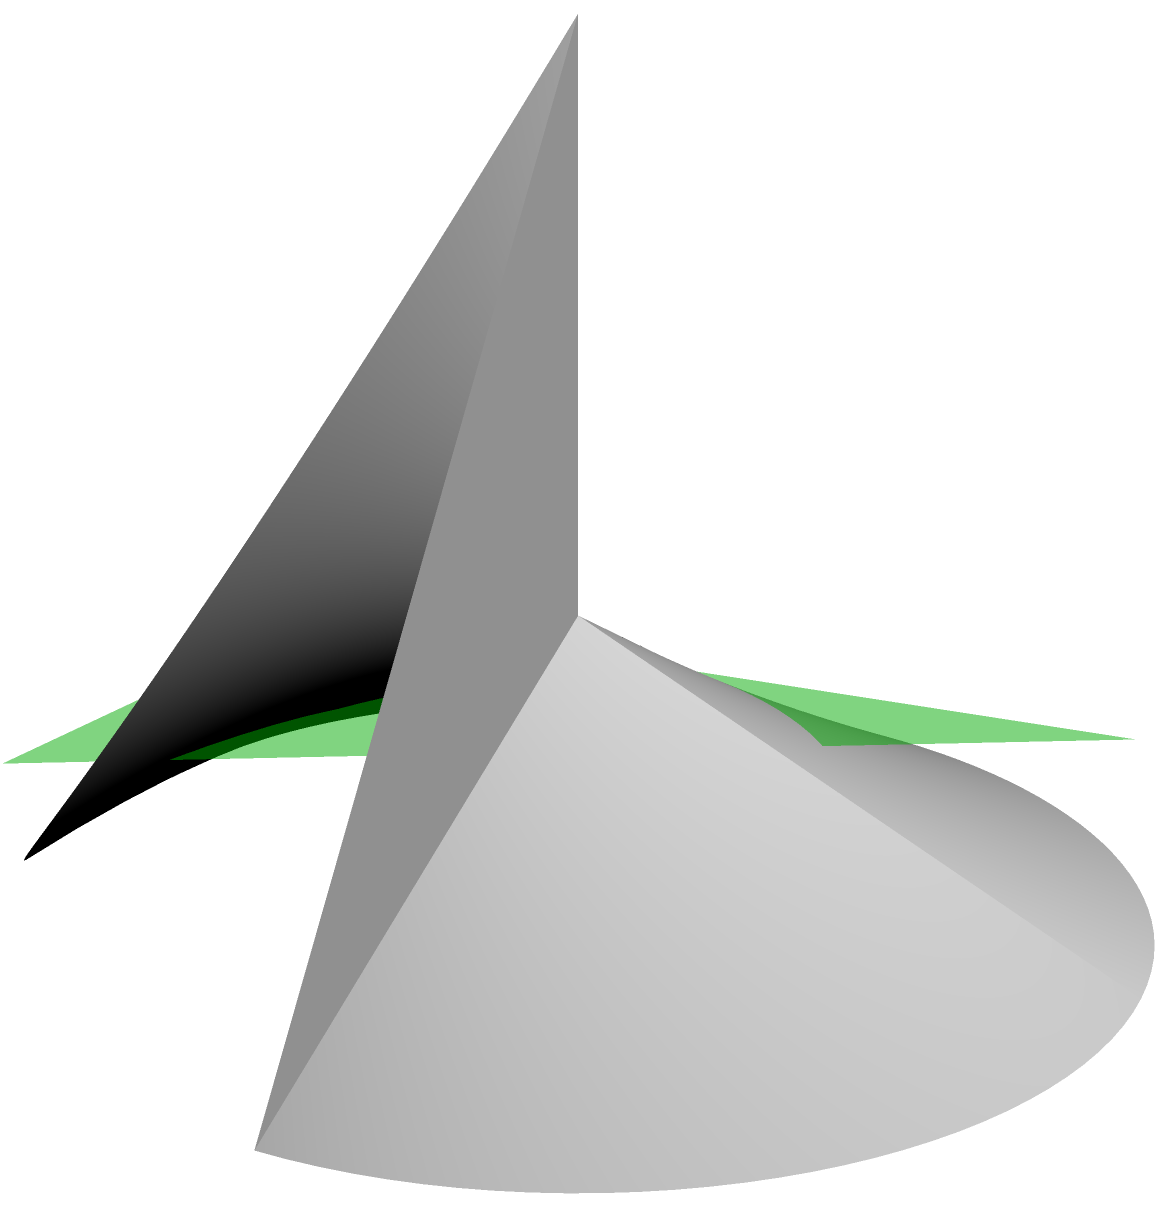A GoPro camera lens has a conical shape with a radius of 2 cm and a height of 3 cm. To optimize the field of view for action shots, the lens is cut at an angle, creating an elliptical surface. If the cutting plane is tilted 30° from the horizontal and passes through the midpoint of the cone's height, what is the surface area of the resulting elliptical lens? (Round your answer to the nearest 0.01 cm²) Let's approach this step-by-step:

1) First, we need to find the slant height of the cone:
   $s = \sqrt{r^2 + h^2} = \sqrt{2^2 + 3^2} = \sqrt{13}$ cm

2) The cutting plane passes through the midpoint of the cone's height, so it's 1.5 cm from the base.

3) The semi-major axis (a) of the ellipse will be the radius of the cone at this height:
   $a = 2 - (1.5/3) * 2 = 1$ cm

4) The semi-minor axis (b) can be found using the angle of the cutting plane:
   $b = a \cos(30°) = 1 * \frac{\sqrt{3}}{2} = \frac{\sqrt{3}}{2}$ cm

5) The area of an ellipse is given by the formula: $A = \pi ab$
   $A = \pi * 1 * \frac{\sqrt{3}}{2} = \frac{\pi\sqrt{3}}{2}$ cm²

6) However, this is the area of the flat projection. To find the actual surface area, we need to account for the curvature of the cone.

7) The surface area of an elliptical cut on a cone can be approximated using the formula:
   $SA = \frac{\pi ab}{s^2}(s^2 + h^2)$

8) Substituting our values:
   $SA = \frac{\pi * 1 * \frac{\sqrt{3}}{2}}{(\sqrt{13})^2}((\sqrt{13})^2 + 3^2)$
   $SA = \frac{\pi\sqrt{3}}{2} * \frac{13 + 9}{13} = \frac{\pi\sqrt{3}}{2} * \frac{22}{13}$
   $SA = \frac{11\pi\sqrt{3}}{13}$ cm²

9) Calculating this and rounding to two decimal places:
   $SA \approx 4.62$ cm²
Answer: 4.62 cm² 